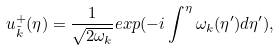Convert formula to latex. <formula><loc_0><loc_0><loc_500><loc_500>u _ { \tilde { k } } ^ { + } ( \eta ) = \frac { 1 } { \sqrt { 2 \omega _ { k } } } e x p ( - i \int ^ { \eta } \omega _ { k } ( \eta ^ { \prime } ) d \eta ^ { \prime } ) ,</formula> 